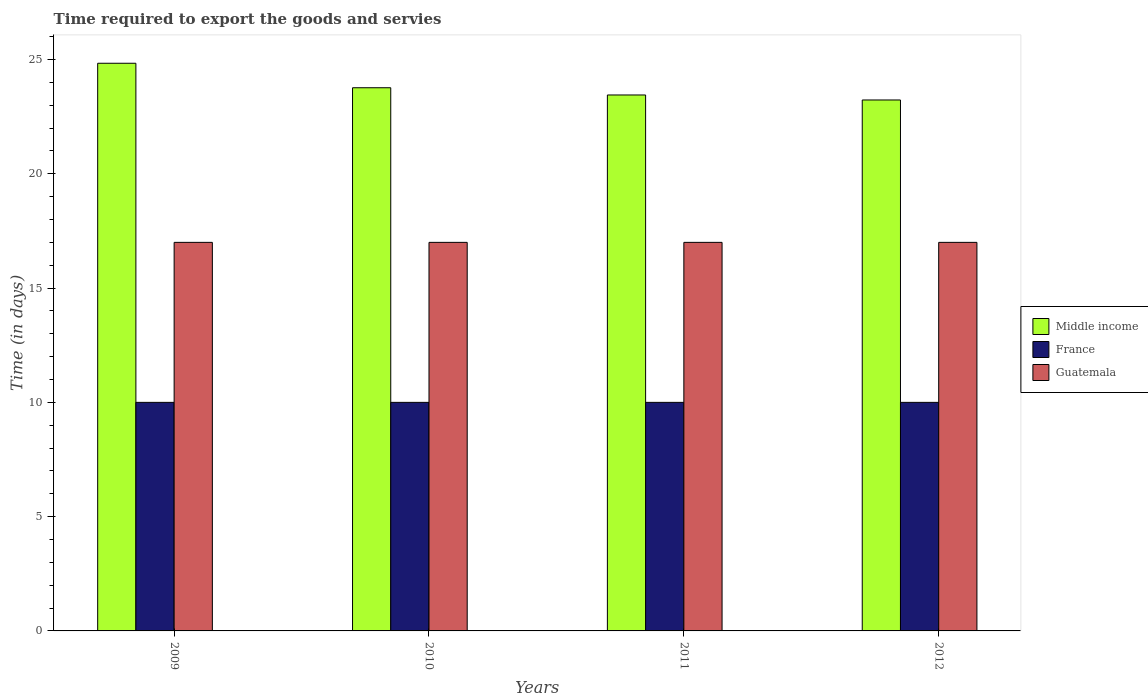How many different coloured bars are there?
Your answer should be very brief. 3. How many groups of bars are there?
Provide a short and direct response. 4. Are the number of bars on each tick of the X-axis equal?
Your response must be concise. Yes. In how many cases, is the number of bars for a given year not equal to the number of legend labels?
Offer a terse response. 0. What is the number of days required to export the goods and services in Middle income in 2011?
Your response must be concise. 23.45. Across all years, what is the maximum number of days required to export the goods and services in Middle income?
Offer a terse response. 24.84. Across all years, what is the minimum number of days required to export the goods and services in Middle income?
Make the answer very short. 23.23. In which year was the number of days required to export the goods and services in Guatemala minimum?
Keep it short and to the point. 2009. What is the total number of days required to export the goods and services in Guatemala in the graph?
Ensure brevity in your answer.  68. What is the difference between the number of days required to export the goods and services in Guatemala in 2011 and the number of days required to export the goods and services in Middle income in 2009?
Your answer should be very brief. -7.84. In the year 2011, what is the difference between the number of days required to export the goods and services in Guatemala and number of days required to export the goods and services in France?
Provide a short and direct response. 7. In how many years, is the number of days required to export the goods and services in Middle income greater than 24 days?
Provide a short and direct response. 1. What is the ratio of the number of days required to export the goods and services in Middle income in 2010 to that in 2012?
Provide a succinct answer. 1.02. Is the difference between the number of days required to export the goods and services in Guatemala in 2011 and 2012 greater than the difference between the number of days required to export the goods and services in France in 2011 and 2012?
Keep it short and to the point. No. What is the difference between the highest and the second highest number of days required to export the goods and services in France?
Keep it short and to the point. 0. What is the difference between the highest and the lowest number of days required to export the goods and services in France?
Make the answer very short. 0. What does the 3rd bar from the left in 2010 represents?
Your answer should be very brief. Guatemala. What does the 1st bar from the right in 2012 represents?
Make the answer very short. Guatemala. Is it the case that in every year, the sum of the number of days required to export the goods and services in France and number of days required to export the goods and services in Middle income is greater than the number of days required to export the goods and services in Guatemala?
Your response must be concise. Yes. How many bars are there?
Offer a terse response. 12. What is the difference between two consecutive major ticks on the Y-axis?
Your answer should be compact. 5. Does the graph contain grids?
Provide a short and direct response. No. What is the title of the graph?
Give a very brief answer. Time required to export the goods and servies. Does "Bahrain" appear as one of the legend labels in the graph?
Your answer should be compact. No. What is the label or title of the Y-axis?
Your answer should be very brief. Time (in days). What is the Time (in days) in Middle income in 2009?
Provide a succinct answer. 24.84. What is the Time (in days) of France in 2009?
Offer a very short reply. 10. What is the Time (in days) of Middle income in 2010?
Offer a terse response. 23.77. What is the Time (in days) in Middle income in 2011?
Ensure brevity in your answer.  23.45. What is the Time (in days) of France in 2011?
Ensure brevity in your answer.  10. What is the Time (in days) of Guatemala in 2011?
Your answer should be compact. 17. What is the Time (in days) in Middle income in 2012?
Give a very brief answer. 23.23. What is the Time (in days) of France in 2012?
Provide a short and direct response. 10. Across all years, what is the maximum Time (in days) in Middle income?
Give a very brief answer. 24.84. Across all years, what is the maximum Time (in days) of France?
Offer a very short reply. 10. Across all years, what is the maximum Time (in days) in Guatemala?
Provide a succinct answer. 17. Across all years, what is the minimum Time (in days) in Middle income?
Your answer should be very brief. 23.23. Across all years, what is the minimum Time (in days) in Guatemala?
Ensure brevity in your answer.  17. What is the total Time (in days) in Middle income in the graph?
Your answer should be compact. 95.28. What is the total Time (in days) in France in the graph?
Keep it short and to the point. 40. What is the total Time (in days) of Guatemala in the graph?
Make the answer very short. 68. What is the difference between the Time (in days) in Middle income in 2009 and that in 2010?
Provide a succinct answer. 1.07. What is the difference between the Time (in days) of Guatemala in 2009 and that in 2010?
Provide a succinct answer. 0. What is the difference between the Time (in days) of Middle income in 2009 and that in 2011?
Your answer should be very brief. 1.39. What is the difference between the Time (in days) of Guatemala in 2009 and that in 2011?
Ensure brevity in your answer.  0. What is the difference between the Time (in days) of Middle income in 2009 and that in 2012?
Provide a short and direct response. 1.61. What is the difference between the Time (in days) of France in 2009 and that in 2012?
Make the answer very short. 0. What is the difference between the Time (in days) in Guatemala in 2009 and that in 2012?
Offer a very short reply. 0. What is the difference between the Time (in days) in Middle income in 2010 and that in 2011?
Give a very brief answer. 0.32. What is the difference between the Time (in days) of Guatemala in 2010 and that in 2011?
Offer a very short reply. 0. What is the difference between the Time (in days) of Middle income in 2010 and that in 2012?
Offer a very short reply. 0.54. What is the difference between the Time (in days) in France in 2010 and that in 2012?
Make the answer very short. 0. What is the difference between the Time (in days) in Middle income in 2011 and that in 2012?
Give a very brief answer. 0.22. What is the difference between the Time (in days) of Guatemala in 2011 and that in 2012?
Offer a very short reply. 0. What is the difference between the Time (in days) in Middle income in 2009 and the Time (in days) in France in 2010?
Ensure brevity in your answer.  14.84. What is the difference between the Time (in days) of Middle income in 2009 and the Time (in days) of Guatemala in 2010?
Provide a succinct answer. 7.84. What is the difference between the Time (in days) in Middle income in 2009 and the Time (in days) in France in 2011?
Provide a succinct answer. 14.84. What is the difference between the Time (in days) in Middle income in 2009 and the Time (in days) in Guatemala in 2011?
Keep it short and to the point. 7.84. What is the difference between the Time (in days) of Middle income in 2009 and the Time (in days) of France in 2012?
Your response must be concise. 14.84. What is the difference between the Time (in days) of Middle income in 2009 and the Time (in days) of Guatemala in 2012?
Your answer should be very brief. 7.84. What is the difference between the Time (in days) in France in 2009 and the Time (in days) in Guatemala in 2012?
Your answer should be compact. -7. What is the difference between the Time (in days) in Middle income in 2010 and the Time (in days) in France in 2011?
Offer a terse response. 13.77. What is the difference between the Time (in days) of Middle income in 2010 and the Time (in days) of Guatemala in 2011?
Your response must be concise. 6.77. What is the difference between the Time (in days) of France in 2010 and the Time (in days) of Guatemala in 2011?
Keep it short and to the point. -7. What is the difference between the Time (in days) in Middle income in 2010 and the Time (in days) in France in 2012?
Provide a short and direct response. 13.77. What is the difference between the Time (in days) of Middle income in 2010 and the Time (in days) of Guatemala in 2012?
Your answer should be very brief. 6.77. What is the difference between the Time (in days) of Middle income in 2011 and the Time (in days) of France in 2012?
Your answer should be very brief. 13.45. What is the difference between the Time (in days) in Middle income in 2011 and the Time (in days) in Guatemala in 2012?
Provide a short and direct response. 6.45. What is the difference between the Time (in days) in France in 2011 and the Time (in days) in Guatemala in 2012?
Provide a short and direct response. -7. What is the average Time (in days) of Middle income per year?
Your answer should be compact. 23.82. In the year 2009, what is the difference between the Time (in days) of Middle income and Time (in days) of France?
Provide a short and direct response. 14.84. In the year 2009, what is the difference between the Time (in days) of Middle income and Time (in days) of Guatemala?
Offer a terse response. 7.84. In the year 2009, what is the difference between the Time (in days) of France and Time (in days) of Guatemala?
Offer a terse response. -7. In the year 2010, what is the difference between the Time (in days) of Middle income and Time (in days) of France?
Offer a very short reply. 13.77. In the year 2010, what is the difference between the Time (in days) of Middle income and Time (in days) of Guatemala?
Ensure brevity in your answer.  6.77. In the year 2011, what is the difference between the Time (in days) in Middle income and Time (in days) in France?
Give a very brief answer. 13.45. In the year 2011, what is the difference between the Time (in days) of Middle income and Time (in days) of Guatemala?
Provide a short and direct response. 6.45. In the year 2012, what is the difference between the Time (in days) in Middle income and Time (in days) in France?
Your response must be concise. 13.23. In the year 2012, what is the difference between the Time (in days) in Middle income and Time (in days) in Guatemala?
Offer a very short reply. 6.23. In the year 2012, what is the difference between the Time (in days) in France and Time (in days) in Guatemala?
Offer a very short reply. -7. What is the ratio of the Time (in days) in Middle income in 2009 to that in 2010?
Your answer should be compact. 1.05. What is the ratio of the Time (in days) of Guatemala in 2009 to that in 2010?
Keep it short and to the point. 1. What is the ratio of the Time (in days) in Middle income in 2009 to that in 2011?
Provide a succinct answer. 1.06. What is the ratio of the Time (in days) of France in 2009 to that in 2011?
Your answer should be very brief. 1. What is the ratio of the Time (in days) in Middle income in 2009 to that in 2012?
Keep it short and to the point. 1.07. What is the ratio of the Time (in days) of Guatemala in 2009 to that in 2012?
Make the answer very short. 1. What is the ratio of the Time (in days) in Middle income in 2010 to that in 2011?
Offer a terse response. 1.01. What is the ratio of the Time (in days) in Middle income in 2010 to that in 2012?
Your answer should be compact. 1.02. What is the ratio of the Time (in days) in France in 2010 to that in 2012?
Provide a succinct answer. 1. What is the ratio of the Time (in days) in Guatemala in 2010 to that in 2012?
Provide a succinct answer. 1. What is the ratio of the Time (in days) of Middle income in 2011 to that in 2012?
Offer a terse response. 1.01. What is the difference between the highest and the second highest Time (in days) of Middle income?
Offer a terse response. 1.07. What is the difference between the highest and the second highest Time (in days) of France?
Provide a short and direct response. 0. What is the difference between the highest and the second highest Time (in days) of Guatemala?
Your answer should be compact. 0. What is the difference between the highest and the lowest Time (in days) of Middle income?
Make the answer very short. 1.61. 